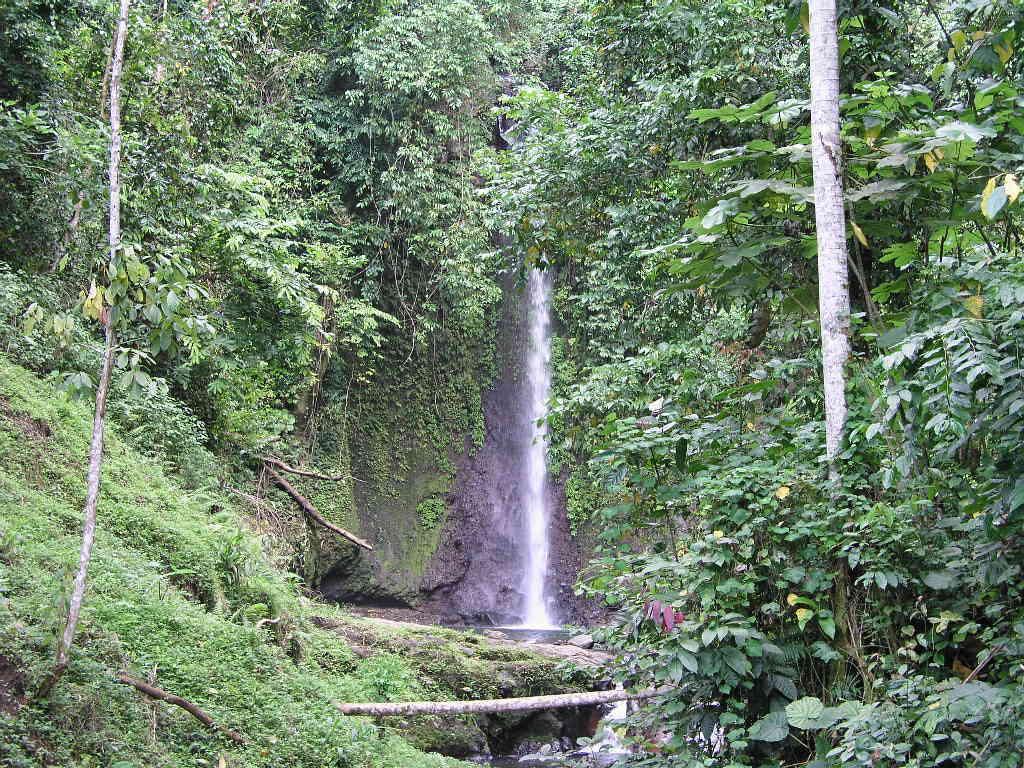Please provide a concise description of this image. In this image there is grass, plants, trees, waterfall. 